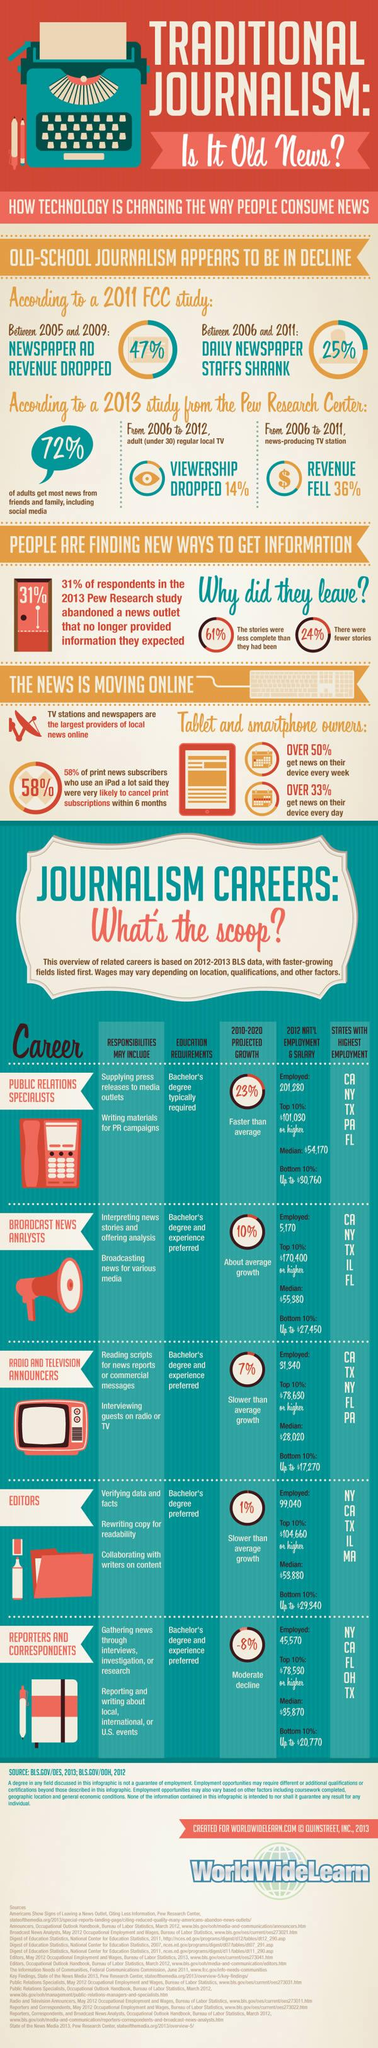Identify some key points in this picture. New York is the state that ranks highest in the recruitment of editors, reporters, and correspondents. The career with the second highest projected average growth is that of a Broadcast News Analyst. 